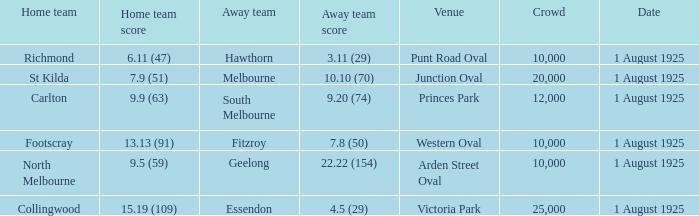Can you give me this table as a dict? {'header': ['Home team', 'Home team score', 'Away team', 'Away team score', 'Venue', 'Crowd', 'Date'], 'rows': [['Richmond', '6.11 (47)', 'Hawthorn', '3.11 (29)', 'Punt Road Oval', '10,000', '1 August 1925'], ['St Kilda', '7.9 (51)', 'Melbourne', '10.10 (70)', 'Junction Oval', '20,000', '1 August 1925'], ['Carlton', '9.9 (63)', 'South Melbourne', '9.20 (74)', 'Princes Park', '12,000', '1 August 1925'], ['Footscray', '13.13 (91)', 'Fitzroy', '7.8 (50)', 'Western Oval', '10,000', '1 August 1925'], ['North Melbourne', '9.5 (59)', 'Geelong', '22.22 (154)', 'Arden Street Oval', '10,000', '1 August 1925'], ['Collingwood', '15.19 (109)', 'Essendon', '4.5 (29)', 'Victoria Park', '25,000', '1 August 1925']]} At the match where the away team scored 4.5 (29), what was the crowd size? 1.0. 